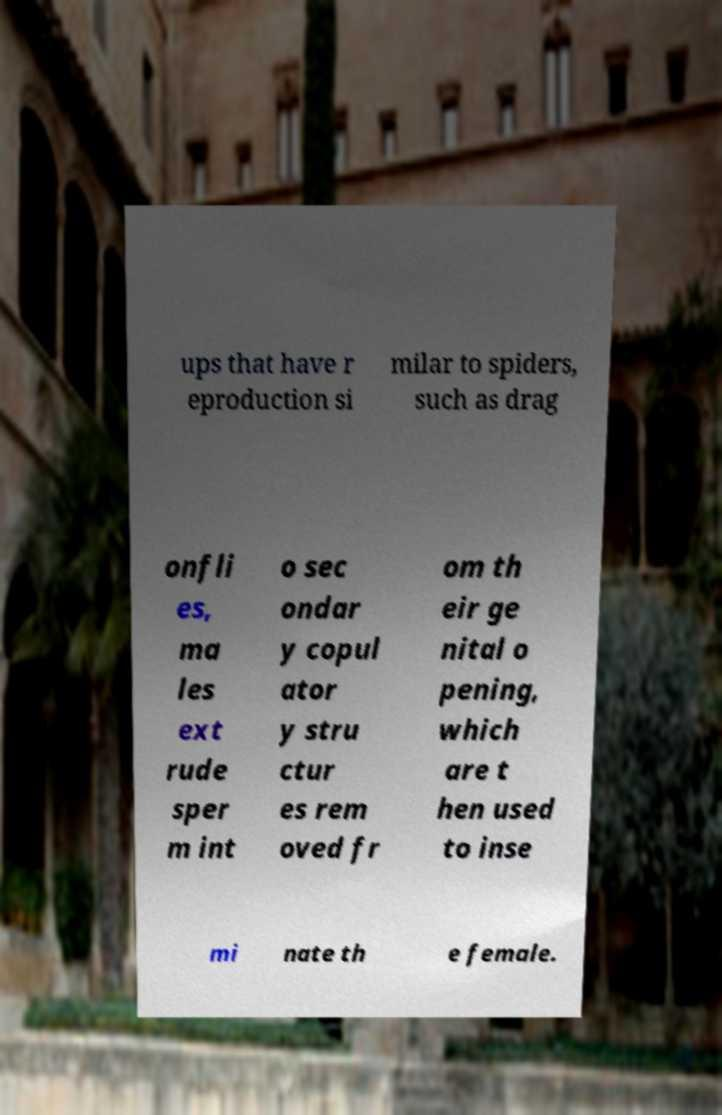Could you extract and type out the text from this image? ups that have r eproduction si milar to spiders, such as drag onfli es, ma les ext rude sper m int o sec ondar y copul ator y stru ctur es rem oved fr om th eir ge nital o pening, which are t hen used to inse mi nate th e female. 